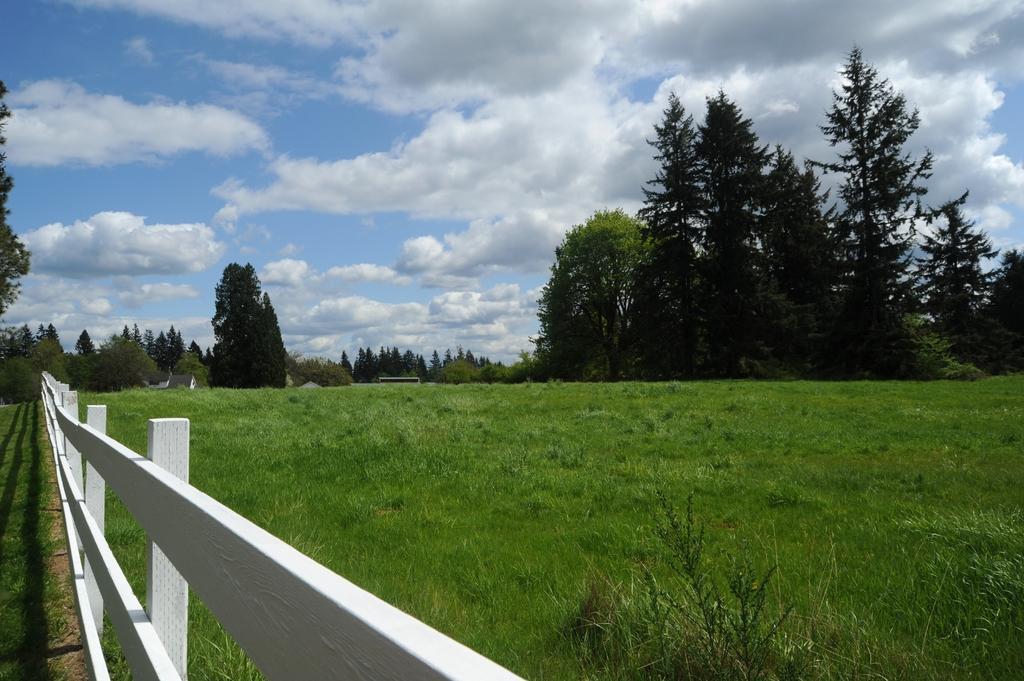Please provide a concise description of this image. In this image we can see a wooden fencing on the left side. On the ground there is grass. In the background there are trees and sky with clouds. 